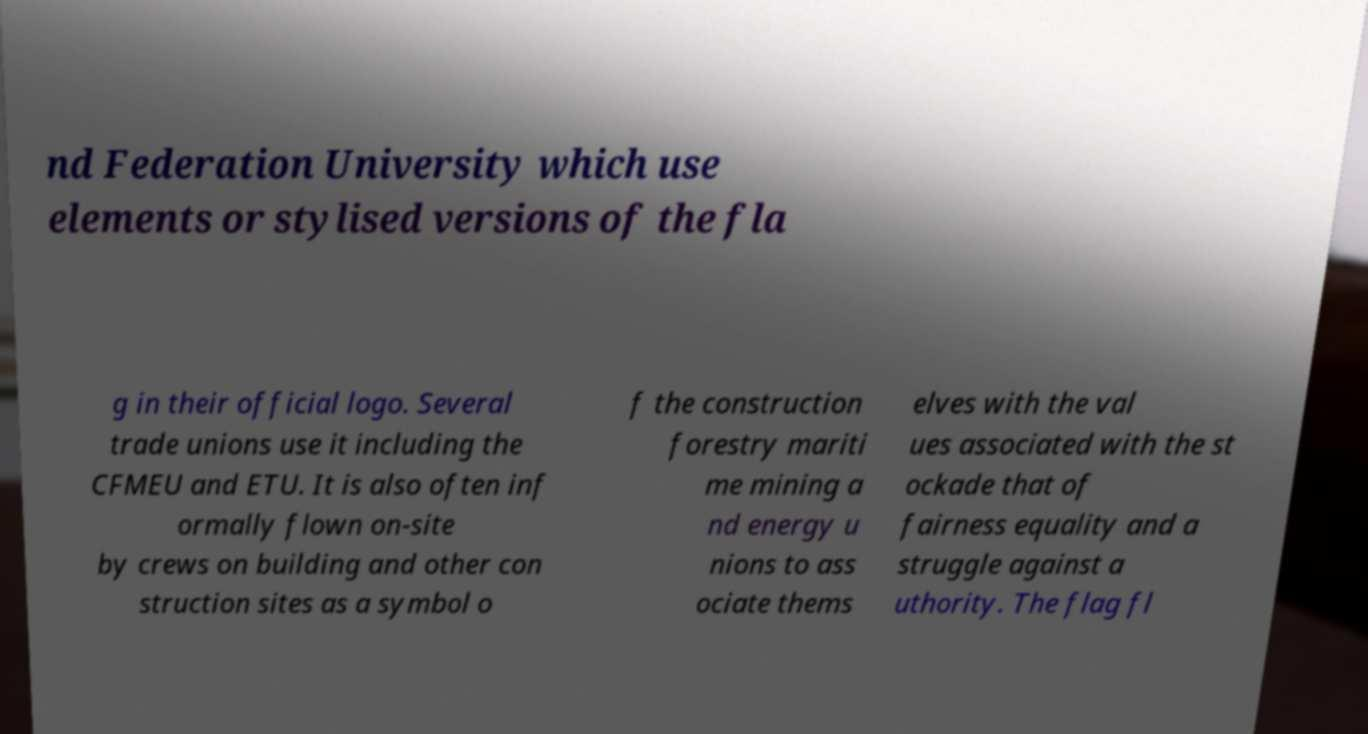Can you read and provide the text displayed in the image?This photo seems to have some interesting text. Can you extract and type it out for me? nd Federation University which use elements or stylised versions of the fla g in their official logo. Several trade unions use it including the CFMEU and ETU. It is also often inf ormally flown on-site by crews on building and other con struction sites as a symbol o f the construction forestry mariti me mining a nd energy u nions to ass ociate thems elves with the val ues associated with the st ockade that of fairness equality and a struggle against a uthority. The flag fl 